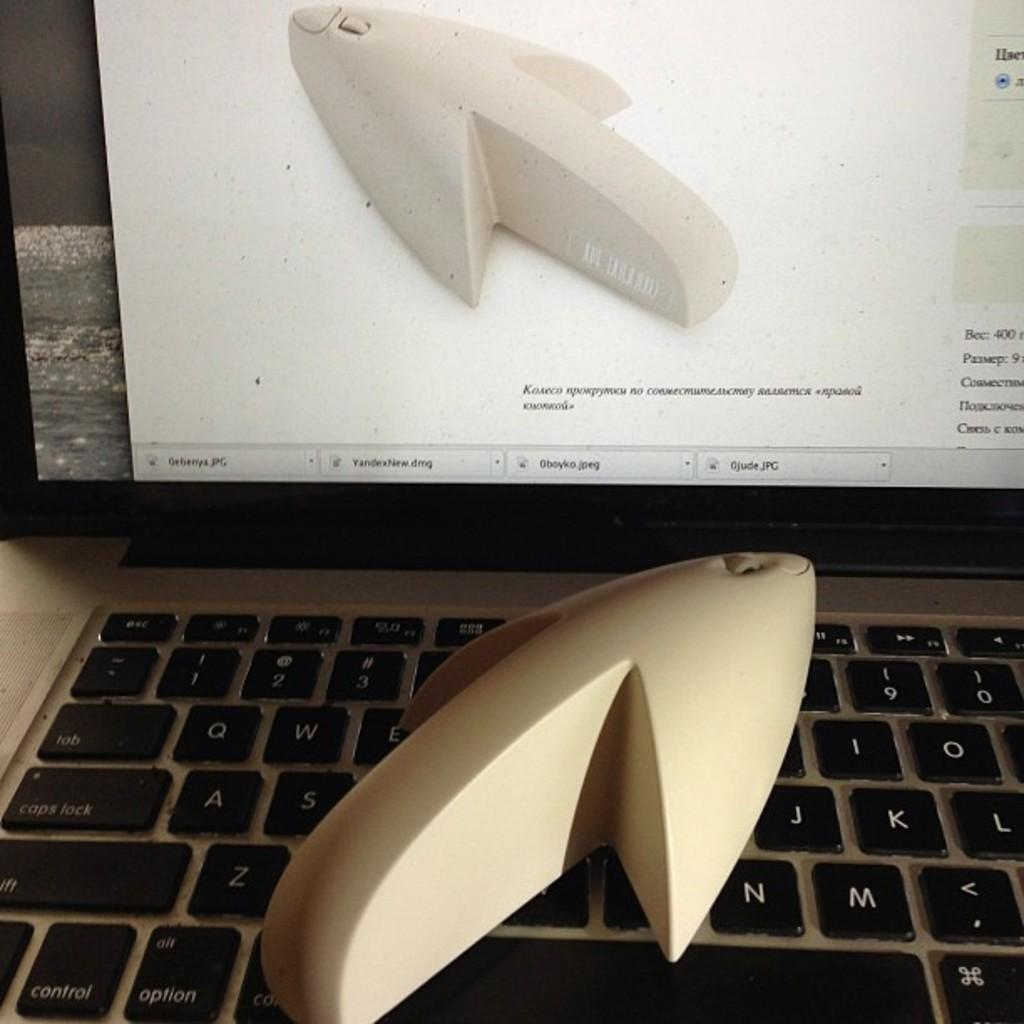<image>
Write a terse but informative summary of the picture. A pointer sits on a laptop keyboard between the "s" and the "j" keys. 